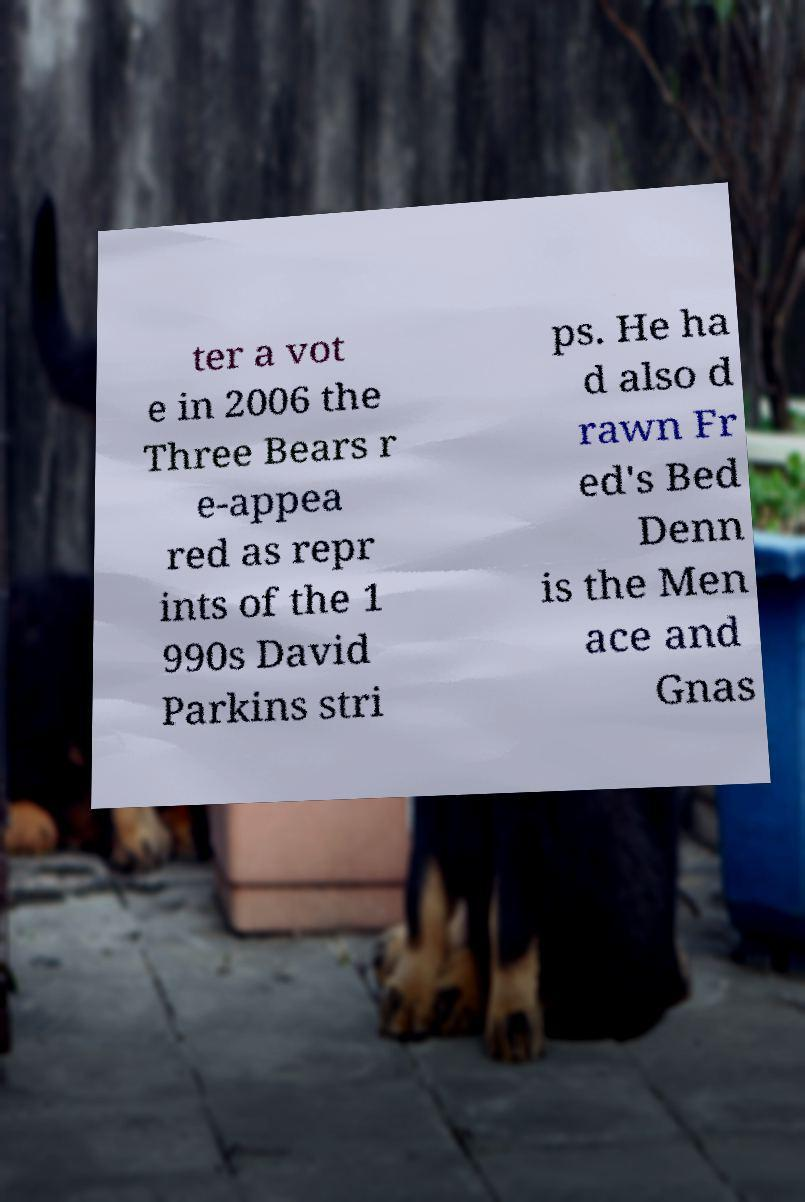Can you accurately transcribe the text from the provided image for me? ter a vot e in 2006 the Three Bears r e-appea red as repr ints of the 1 990s David Parkins stri ps. He ha d also d rawn Fr ed's Bed Denn is the Men ace and Gnas 